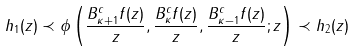<formula> <loc_0><loc_0><loc_500><loc_500>h _ { 1 } ( z ) \prec \phi \left ( \frac { B _ { \kappa + 1 } ^ { c } f ( z ) } { z } , \frac { B _ { \kappa } ^ { c } f ( z ) } { z } , \frac { B _ { \kappa - 1 } ^ { c } f ( z ) } { z } ; z \right ) \prec h _ { 2 } ( z )</formula> 